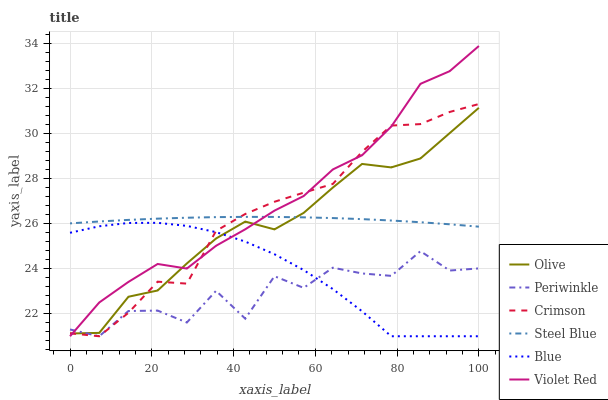Does Periwinkle have the minimum area under the curve?
Answer yes or no. Yes. Does Violet Red have the maximum area under the curve?
Answer yes or no. Yes. Does Steel Blue have the minimum area under the curve?
Answer yes or no. No. Does Steel Blue have the maximum area under the curve?
Answer yes or no. No. Is Steel Blue the smoothest?
Answer yes or no. Yes. Is Periwinkle the roughest?
Answer yes or no. Yes. Is Violet Red the smoothest?
Answer yes or no. No. Is Violet Red the roughest?
Answer yes or no. No. Does Blue have the lowest value?
Answer yes or no. Yes. Does Steel Blue have the lowest value?
Answer yes or no. No. Does Violet Red have the highest value?
Answer yes or no. Yes. Does Steel Blue have the highest value?
Answer yes or no. No. Is Blue less than Steel Blue?
Answer yes or no. Yes. Is Steel Blue greater than Periwinkle?
Answer yes or no. Yes. Does Olive intersect Crimson?
Answer yes or no. Yes. Is Olive less than Crimson?
Answer yes or no. No. Is Olive greater than Crimson?
Answer yes or no. No. Does Blue intersect Steel Blue?
Answer yes or no. No. 